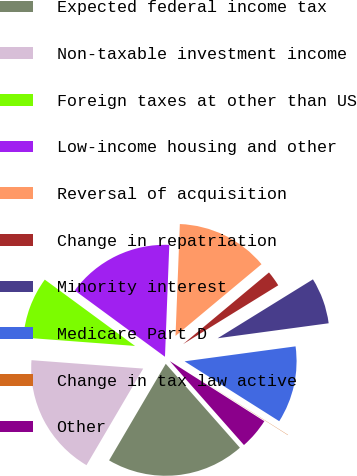<chart> <loc_0><loc_0><loc_500><loc_500><pie_chart><fcel>Expected federal income tax<fcel>Non-taxable investment income<fcel>Foreign taxes at other than US<fcel>Low-income housing and other<fcel>Reversal of acquisition<fcel>Change in repatriation<fcel>Minority interest<fcel>Medicare Part D<fcel>Change in tax law active<fcel>Other<nl><fcel>19.96%<fcel>17.75%<fcel>8.89%<fcel>15.53%<fcel>13.32%<fcel>2.25%<fcel>6.68%<fcel>11.11%<fcel>0.04%<fcel>4.47%<nl></chart> 